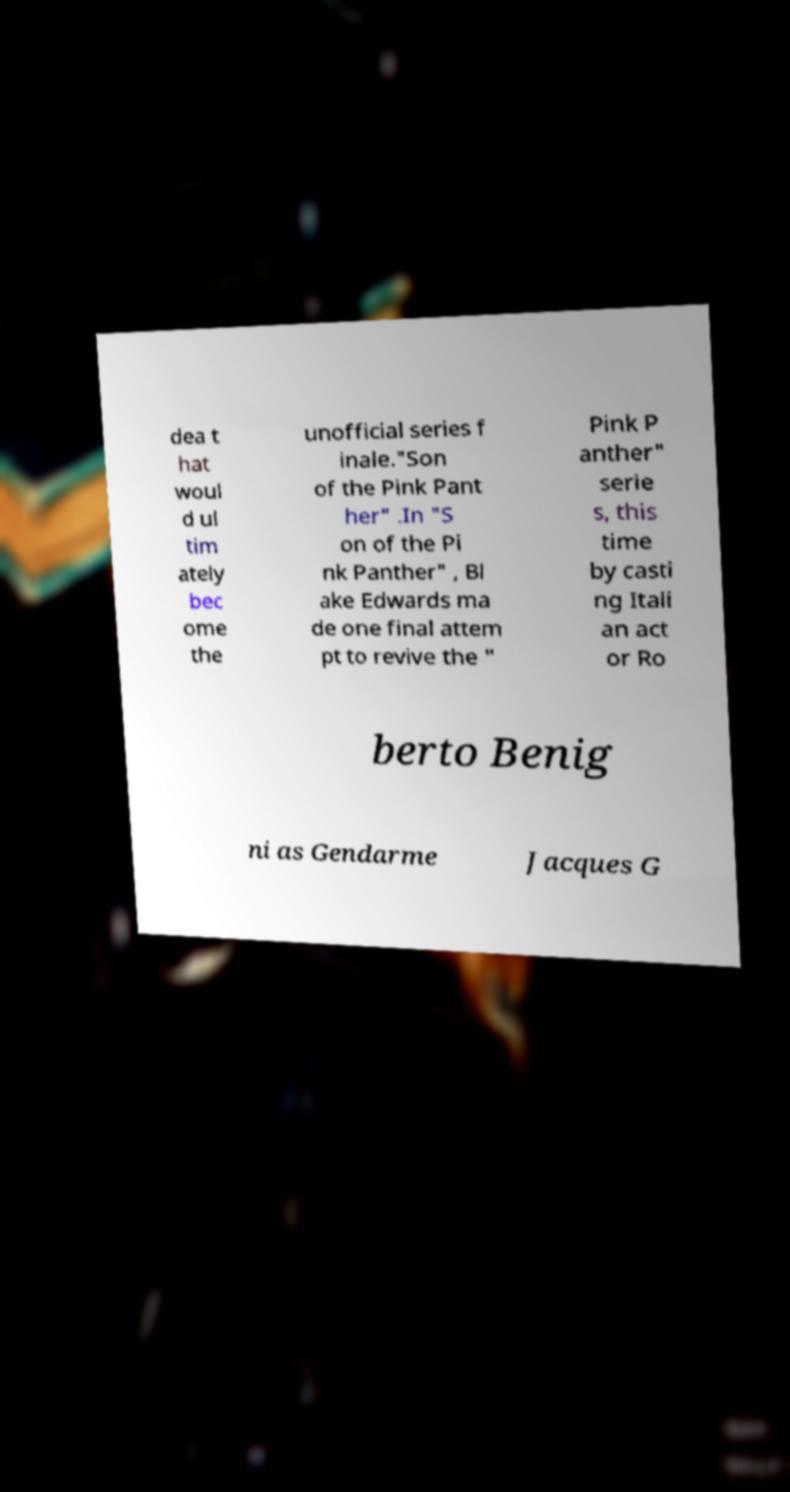Could you extract and type out the text from this image? dea t hat woul d ul tim ately bec ome the unofficial series f inale."Son of the Pink Pant her" .In "S on of the Pi nk Panther" , Bl ake Edwards ma de one final attem pt to revive the " Pink P anther" serie s, this time by casti ng Itali an act or Ro berto Benig ni as Gendarme Jacques G 